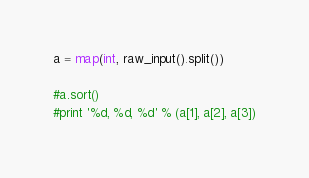<code> <loc_0><loc_0><loc_500><loc_500><_Python_>a = map(int, raw_input().split())
  
#a.sort()
#print '%d, %d, %d' % (a[1], a[2], a[3])</code> 